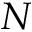<formula> <loc_0><loc_0><loc_500><loc_500>N</formula> 